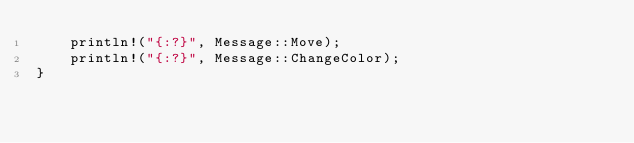<code> <loc_0><loc_0><loc_500><loc_500><_Rust_>    println!("{:?}", Message::Move);
    println!("{:?}", Message::ChangeColor);
}

</code> 